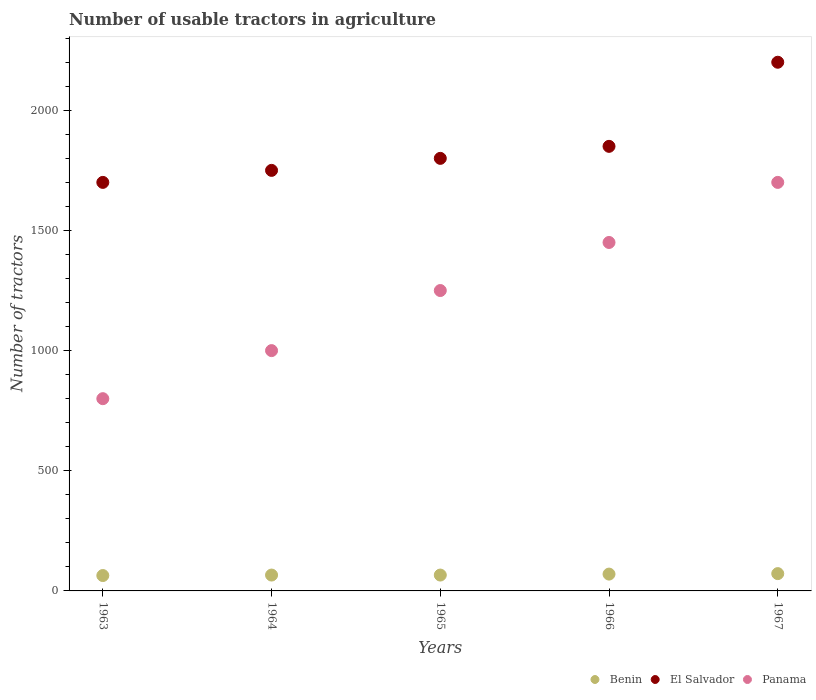How many different coloured dotlines are there?
Give a very brief answer. 3. Is the number of dotlines equal to the number of legend labels?
Your answer should be compact. Yes. What is the number of usable tractors in agriculture in El Salvador in 1964?
Keep it short and to the point. 1750. Across all years, what is the minimum number of usable tractors in agriculture in El Salvador?
Your answer should be compact. 1700. In which year was the number of usable tractors in agriculture in El Salvador maximum?
Offer a very short reply. 1967. What is the total number of usable tractors in agriculture in Benin in the graph?
Make the answer very short. 338. What is the difference between the number of usable tractors in agriculture in Benin in 1965 and that in 1966?
Your response must be concise. -4. What is the difference between the number of usable tractors in agriculture in Benin in 1966 and the number of usable tractors in agriculture in Panama in 1964?
Provide a succinct answer. -930. What is the average number of usable tractors in agriculture in El Salvador per year?
Your answer should be very brief. 1860. In the year 1967, what is the difference between the number of usable tractors in agriculture in El Salvador and number of usable tractors in agriculture in Panama?
Offer a very short reply. 500. In how many years, is the number of usable tractors in agriculture in El Salvador greater than 1400?
Provide a short and direct response. 5. What is the ratio of the number of usable tractors in agriculture in El Salvador in 1964 to that in 1966?
Offer a terse response. 0.95. What is the difference between the highest and the second highest number of usable tractors in agriculture in Benin?
Offer a very short reply. 2. What is the difference between the highest and the lowest number of usable tractors in agriculture in El Salvador?
Your answer should be compact. 500. In how many years, is the number of usable tractors in agriculture in Benin greater than the average number of usable tractors in agriculture in Benin taken over all years?
Offer a very short reply. 2. Is the sum of the number of usable tractors in agriculture in Benin in 1965 and 1966 greater than the maximum number of usable tractors in agriculture in El Salvador across all years?
Your response must be concise. No. Does the number of usable tractors in agriculture in Panama monotonically increase over the years?
Provide a short and direct response. Yes. Is the number of usable tractors in agriculture in Benin strictly less than the number of usable tractors in agriculture in El Salvador over the years?
Ensure brevity in your answer.  Yes. Does the graph contain grids?
Offer a terse response. No. Where does the legend appear in the graph?
Your answer should be very brief. Bottom right. How are the legend labels stacked?
Your answer should be very brief. Horizontal. What is the title of the graph?
Offer a terse response. Number of usable tractors in agriculture. What is the label or title of the Y-axis?
Keep it short and to the point. Number of tractors. What is the Number of tractors of Benin in 1963?
Offer a terse response. 64. What is the Number of tractors of El Salvador in 1963?
Ensure brevity in your answer.  1700. What is the Number of tractors in Panama in 1963?
Provide a short and direct response. 800. What is the Number of tractors in El Salvador in 1964?
Your answer should be very brief. 1750. What is the Number of tractors in Benin in 1965?
Provide a succinct answer. 66. What is the Number of tractors of El Salvador in 1965?
Your answer should be very brief. 1800. What is the Number of tractors of Panama in 1965?
Provide a short and direct response. 1250. What is the Number of tractors in Benin in 1966?
Provide a short and direct response. 70. What is the Number of tractors of El Salvador in 1966?
Make the answer very short. 1850. What is the Number of tractors of Panama in 1966?
Offer a very short reply. 1450. What is the Number of tractors in Benin in 1967?
Ensure brevity in your answer.  72. What is the Number of tractors of El Salvador in 1967?
Provide a succinct answer. 2200. What is the Number of tractors of Panama in 1967?
Your answer should be compact. 1700. Across all years, what is the maximum Number of tractors of El Salvador?
Ensure brevity in your answer.  2200. Across all years, what is the maximum Number of tractors in Panama?
Your answer should be very brief. 1700. Across all years, what is the minimum Number of tractors in El Salvador?
Your answer should be very brief. 1700. Across all years, what is the minimum Number of tractors of Panama?
Make the answer very short. 800. What is the total Number of tractors of Benin in the graph?
Offer a very short reply. 338. What is the total Number of tractors in El Salvador in the graph?
Provide a short and direct response. 9300. What is the total Number of tractors in Panama in the graph?
Offer a terse response. 6200. What is the difference between the Number of tractors of Benin in 1963 and that in 1964?
Provide a short and direct response. -2. What is the difference between the Number of tractors in El Salvador in 1963 and that in 1964?
Provide a succinct answer. -50. What is the difference between the Number of tractors of Panama in 1963 and that in 1964?
Offer a terse response. -200. What is the difference between the Number of tractors of El Salvador in 1963 and that in 1965?
Your answer should be compact. -100. What is the difference between the Number of tractors of Panama in 1963 and that in 1965?
Provide a succinct answer. -450. What is the difference between the Number of tractors in Benin in 1963 and that in 1966?
Offer a terse response. -6. What is the difference between the Number of tractors of El Salvador in 1963 and that in 1966?
Offer a terse response. -150. What is the difference between the Number of tractors in Panama in 1963 and that in 1966?
Keep it short and to the point. -650. What is the difference between the Number of tractors of Benin in 1963 and that in 1967?
Offer a terse response. -8. What is the difference between the Number of tractors in El Salvador in 1963 and that in 1967?
Offer a very short reply. -500. What is the difference between the Number of tractors in Panama in 1963 and that in 1967?
Your answer should be very brief. -900. What is the difference between the Number of tractors of Panama in 1964 and that in 1965?
Your response must be concise. -250. What is the difference between the Number of tractors in Benin in 1964 and that in 1966?
Make the answer very short. -4. What is the difference between the Number of tractors of El Salvador in 1964 and that in 1966?
Make the answer very short. -100. What is the difference between the Number of tractors of Panama in 1964 and that in 1966?
Make the answer very short. -450. What is the difference between the Number of tractors of El Salvador in 1964 and that in 1967?
Provide a short and direct response. -450. What is the difference between the Number of tractors of Panama in 1964 and that in 1967?
Ensure brevity in your answer.  -700. What is the difference between the Number of tractors in Panama in 1965 and that in 1966?
Offer a very short reply. -200. What is the difference between the Number of tractors in El Salvador in 1965 and that in 1967?
Offer a terse response. -400. What is the difference between the Number of tractors of Panama in 1965 and that in 1967?
Offer a terse response. -450. What is the difference between the Number of tractors of Benin in 1966 and that in 1967?
Make the answer very short. -2. What is the difference between the Number of tractors in El Salvador in 1966 and that in 1967?
Your answer should be very brief. -350. What is the difference between the Number of tractors in Panama in 1966 and that in 1967?
Ensure brevity in your answer.  -250. What is the difference between the Number of tractors of Benin in 1963 and the Number of tractors of El Salvador in 1964?
Keep it short and to the point. -1686. What is the difference between the Number of tractors of Benin in 1963 and the Number of tractors of Panama in 1964?
Provide a succinct answer. -936. What is the difference between the Number of tractors of El Salvador in 1963 and the Number of tractors of Panama in 1964?
Provide a succinct answer. 700. What is the difference between the Number of tractors in Benin in 1963 and the Number of tractors in El Salvador in 1965?
Make the answer very short. -1736. What is the difference between the Number of tractors in Benin in 1963 and the Number of tractors in Panama in 1965?
Your answer should be very brief. -1186. What is the difference between the Number of tractors of El Salvador in 1963 and the Number of tractors of Panama in 1965?
Your answer should be compact. 450. What is the difference between the Number of tractors in Benin in 1963 and the Number of tractors in El Salvador in 1966?
Keep it short and to the point. -1786. What is the difference between the Number of tractors in Benin in 1963 and the Number of tractors in Panama in 1966?
Keep it short and to the point. -1386. What is the difference between the Number of tractors in El Salvador in 1963 and the Number of tractors in Panama in 1966?
Provide a succinct answer. 250. What is the difference between the Number of tractors of Benin in 1963 and the Number of tractors of El Salvador in 1967?
Provide a short and direct response. -2136. What is the difference between the Number of tractors of Benin in 1963 and the Number of tractors of Panama in 1967?
Your answer should be very brief. -1636. What is the difference between the Number of tractors of El Salvador in 1963 and the Number of tractors of Panama in 1967?
Offer a terse response. 0. What is the difference between the Number of tractors in Benin in 1964 and the Number of tractors in El Salvador in 1965?
Your answer should be compact. -1734. What is the difference between the Number of tractors in Benin in 1964 and the Number of tractors in Panama in 1965?
Make the answer very short. -1184. What is the difference between the Number of tractors of Benin in 1964 and the Number of tractors of El Salvador in 1966?
Your answer should be very brief. -1784. What is the difference between the Number of tractors of Benin in 1964 and the Number of tractors of Panama in 1966?
Provide a succinct answer. -1384. What is the difference between the Number of tractors of El Salvador in 1964 and the Number of tractors of Panama in 1966?
Make the answer very short. 300. What is the difference between the Number of tractors of Benin in 1964 and the Number of tractors of El Salvador in 1967?
Ensure brevity in your answer.  -2134. What is the difference between the Number of tractors in Benin in 1964 and the Number of tractors in Panama in 1967?
Provide a succinct answer. -1634. What is the difference between the Number of tractors in Benin in 1965 and the Number of tractors in El Salvador in 1966?
Your answer should be compact. -1784. What is the difference between the Number of tractors in Benin in 1965 and the Number of tractors in Panama in 1966?
Provide a short and direct response. -1384. What is the difference between the Number of tractors of El Salvador in 1965 and the Number of tractors of Panama in 1966?
Give a very brief answer. 350. What is the difference between the Number of tractors in Benin in 1965 and the Number of tractors in El Salvador in 1967?
Keep it short and to the point. -2134. What is the difference between the Number of tractors in Benin in 1965 and the Number of tractors in Panama in 1967?
Your response must be concise. -1634. What is the difference between the Number of tractors in El Salvador in 1965 and the Number of tractors in Panama in 1967?
Make the answer very short. 100. What is the difference between the Number of tractors of Benin in 1966 and the Number of tractors of El Salvador in 1967?
Provide a short and direct response. -2130. What is the difference between the Number of tractors of Benin in 1966 and the Number of tractors of Panama in 1967?
Offer a very short reply. -1630. What is the difference between the Number of tractors of El Salvador in 1966 and the Number of tractors of Panama in 1967?
Make the answer very short. 150. What is the average Number of tractors of Benin per year?
Provide a short and direct response. 67.6. What is the average Number of tractors of El Salvador per year?
Give a very brief answer. 1860. What is the average Number of tractors in Panama per year?
Ensure brevity in your answer.  1240. In the year 1963, what is the difference between the Number of tractors of Benin and Number of tractors of El Salvador?
Your answer should be compact. -1636. In the year 1963, what is the difference between the Number of tractors in Benin and Number of tractors in Panama?
Make the answer very short. -736. In the year 1963, what is the difference between the Number of tractors in El Salvador and Number of tractors in Panama?
Ensure brevity in your answer.  900. In the year 1964, what is the difference between the Number of tractors in Benin and Number of tractors in El Salvador?
Your answer should be very brief. -1684. In the year 1964, what is the difference between the Number of tractors of Benin and Number of tractors of Panama?
Make the answer very short. -934. In the year 1964, what is the difference between the Number of tractors of El Salvador and Number of tractors of Panama?
Your answer should be compact. 750. In the year 1965, what is the difference between the Number of tractors of Benin and Number of tractors of El Salvador?
Give a very brief answer. -1734. In the year 1965, what is the difference between the Number of tractors in Benin and Number of tractors in Panama?
Your response must be concise. -1184. In the year 1965, what is the difference between the Number of tractors of El Salvador and Number of tractors of Panama?
Offer a very short reply. 550. In the year 1966, what is the difference between the Number of tractors of Benin and Number of tractors of El Salvador?
Give a very brief answer. -1780. In the year 1966, what is the difference between the Number of tractors in Benin and Number of tractors in Panama?
Make the answer very short. -1380. In the year 1966, what is the difference between the Number of tractors in El Salvador and Number of tractors in Panama?
Your response must be concise. 400. In the year 1967, what is the difference between the Number of tractors of Benin and Number of tractors of El Salvador?
Keep it short and to the point. -2128. In the year 1967, what is the difference between the Number of tractors in Benin and Number of tractors in Panama?
Your answer should be very brief. -1628. In the year 1967, what is the difference between the Number of tractors in El Salvador and Number of tractors in Panama?
Provide a short and direct response. 500. What is the ratio of the Number of tractors of Benin in 1963 to that in 1964?
Your answer should be compact. 0.97. What is the ratio of the Number of tractors in El Salvador in 1963 to that in 1964?
Ensure brevity in your answer.  0.97. What is the ratio of the Number of tractors in Benin in 1963 to that in 1965?
Offer a terse response. 0.97. What is the ratio of the Number of tractors in Panama in 1963 to that in 1965?
Offer a very short reply. 0.64. What is the ratio of the Number of tractors of Benin in 1963 to that in 1966?
Make the answer very short. 0.91. What is the ratio of the Number of tractors of El Salvador in 1963 to that in 1966?
Ensure brevity in your answer.  0.92. What is the ratio of the Number of tractors in Panama in 1963 to that in 1966?
Ensure brevity in your answer.  0.55. What is the ratio of the Number of tractors of El Salvador in 1963 to that in 1967?
Your answer should be compact. 0.77. What is the ratio of the Number of tractors in Panama in 1963 to that in 1967?
Provide a succinct answer. 0.47. What is the ratio of the Number of tractors in Benin in 1964 to that in 1965?
Your answer should be very brief. 1. What is the ratio of the Number of tractors of El Salvador in 1964 to that in 1965?
Provide a short and direct response. 0.97. What is the ratio of the Number of tractors in Panama in 1964 to that in 1965?
Provide a short and direct response. 0.8. What is the ratio of the Number of tractors of Benin in 1964 to that in 1966?
Offer a terse response. 0.94. What is the ratio of the Number of tractors in El Salvador in 1964 to that in 1966?
Ensure brevity in your answer.  0.95. What is the ratio of the Number of tractors in Panama in 1964 to that in 1966?
Your answer should be very brief. 0.69. What is the ratio of the Number of tractors in El Salvador in 1964 to that in 1967?
Offer a very short reply. 0.8. What is the ratio of the Number of tractors in Panama in 1964 to that in 1967?
Offer a very short reply. 0.59. What is the ratio of the Number of tractors of Benin in 1965 to that in 1966?
Ensure brevity in your answer.  0.94. What is the ratio of the Number of tractors in El Salvador in 1965 to that in 1966?
Your answer should be compact. 0.97. What is the ratio of the Number of tractors in Panama in 1965 to that in 1966?
Make the answer very short. 0.86. What is the ratio of the Number of tractors in Benin in 1965 to that in 1967?
Keep it short and to the point. 0.92. What is the ratio of the Number of tractors in El Salvador in 1965 to that in 1967?
Your answer should be very brief. 0.82. What is the ratio of the Number of tractors in Panama in 1965 to that in 1967?
Your answer should be compact. 0.74. What is the ratio of the Number of tractors of Benin in 1966 to that in 1967?
Offer a very short reply. 0.97. What is the ratio of the Number of tractors in El Salvador in 1966 to that in 1967?
Your answer should be very brief. 0.84. What is the ratio of the Number of tractors of Panama in 1966 to that in 1967?
Your answer should be compact. 0.85. What is the difference between the highest and the second highest Number of tractors of Benin?
Make the answer very short. 2. What is the difference between the highest and the second highest Number of tractors in El Salvador?
Ensure brevity in your answer.  350. What is the difference between the highest and the second highest Number of tractors of Panama?
Keep it short and to the point. 250. What is the difference between the highest and the lowest Number of tractors in Benin?
Ensure brevity in your answer.  8. What is the difference between the highest and the lowest Number of tractors in El Salvador?
Make the answer very short. 500. What is the difference between the highest and the lowest Number of tractors in Panama?
Make the answer very short. 900. 